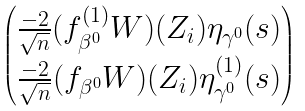<formula> <loc_0><loc_0><loc_500><loc_500>\begin{pmatrix} \frac { - 2 } { \sqrt { n } } ( f _ { \beta ^ { 0 } } ^ { ( 1 ) } W ) ( Z _ { i } ) \eta _ { \gamma ^ { 0 } } ( s ) \\ \frac { - 2 } { \sqrt { n } } ( f _ { \beta ^ { 0 } } W ) ( Z _ { i } ) \eta _ { \gamma ^ { 0 } } ^ { ( 1 ) } ( s ) \end{pmatrix}</formula> 